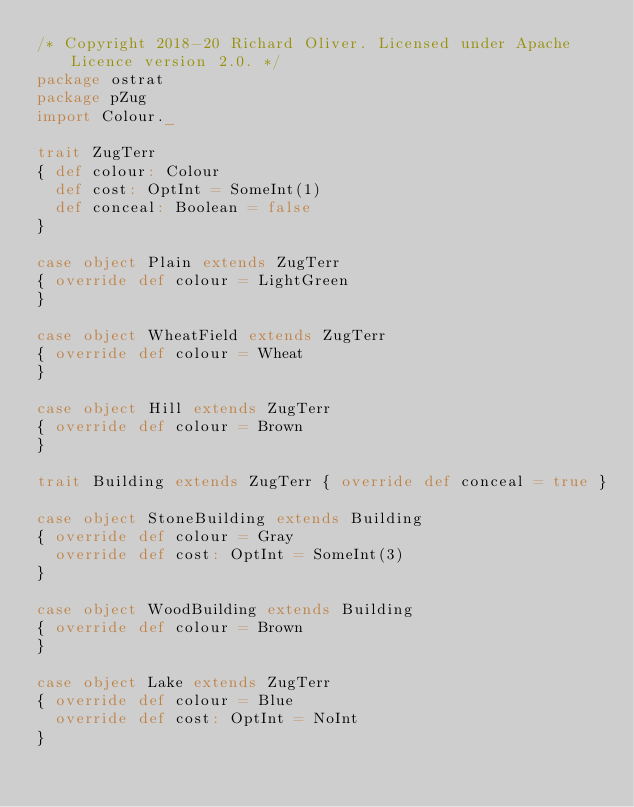Convert code to text. <code><loc_0><loc_0><loc_500><loc_500><_Scala_>/* Copyright 2018-20 Richard Oliver. Licensed under Apache Licence version 2.0. */
package ostrat
package pZug
import Colour._

trait ZugTerr
{ def colour: Colour
  def cost: OptInt = SomeInt(1)
  def conceal: Boolean = false
}

case object Plain extends ZugTerr
{ override def colour = LightGreen
}

case object WheatField extends ZugTerr
{ override def colour = Wheat
}

case object Hill extends ZugTerr
{ override def colour = Brown
}

trait Building extends ZugTerr { override def conceal = true }

case object StoneBuilding extends Building
{ override def colour = Gray
  override def cost: OptInt = SomeInt(3)
}

case object WoodBuilding extends Building
{ override def colour = Brown
}

case object Lake extends ZugTerr
{ override def colour = Blue
  override def cost: OptInt = NoInt
}</code> 